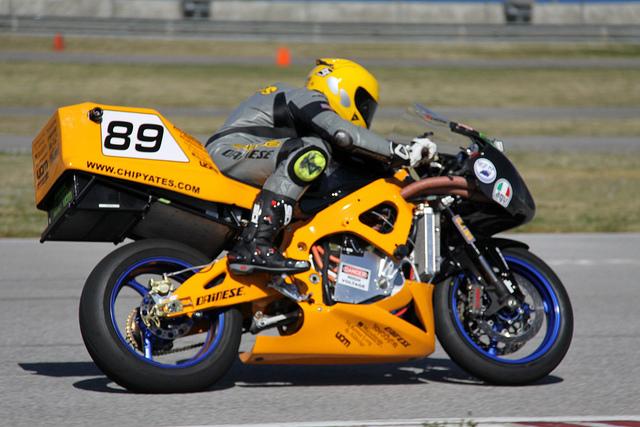What number is on the bike?
Keep it brief. 89. What color are the cones?
Concise answer only. Orange. What colors are the riders jacket?
Give a very brief answer. Gray. Is this nascar?
Quick response, please. No. Subtract 8 from the number. What is the square root of eight less than the large number?
Concise answer only. 9. 